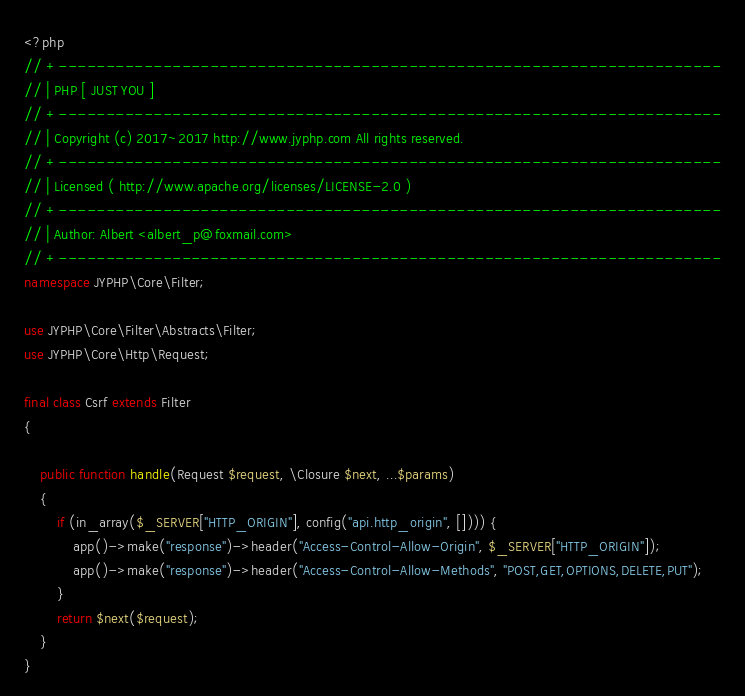<code> <loc_0><loc_0><loc_500><loc_500><_PHP_><?php
// +----------------------------------------------------------------------
// | PHP [ JUST YOU ]
// +----------------------------------------------------------------------
// | Copyright (c) 2017~2017 http://www.jyphp.com All rights reserved.
// +----------------------------------------------------------------------
// | Licensed ( http://www.apache.org/licenses/LICENSE-2.0 )
// +----------------------------------------------------------------------
// | Author: Albert <albert_p@foxmail.com>
// +----------------------------------------------------------------------
namespace JYPHP\Core\Filter;

use JYPHP\Core\Filter\Abstracts\Filter;
use JYPHP\Core\Http\Request;

final class Csrf extends Filter
{

    public function handle(Request $request, \Closure $next, ...$params)
    {
        if (in_array($_SERVER["HTTP_ORIGIN"], config("api.http_origin", []))) {
            app()->make("response")->header("Access-Control-Allow-Origin", $_SERVER["HTTP_ORIGIN"]);
            app()->make("response")->header("Access-Control-Allow-Methods", "POST,GET,OPTIONS,DELETE,PUT");
        }
        return $next($request);
    }
}</code> 